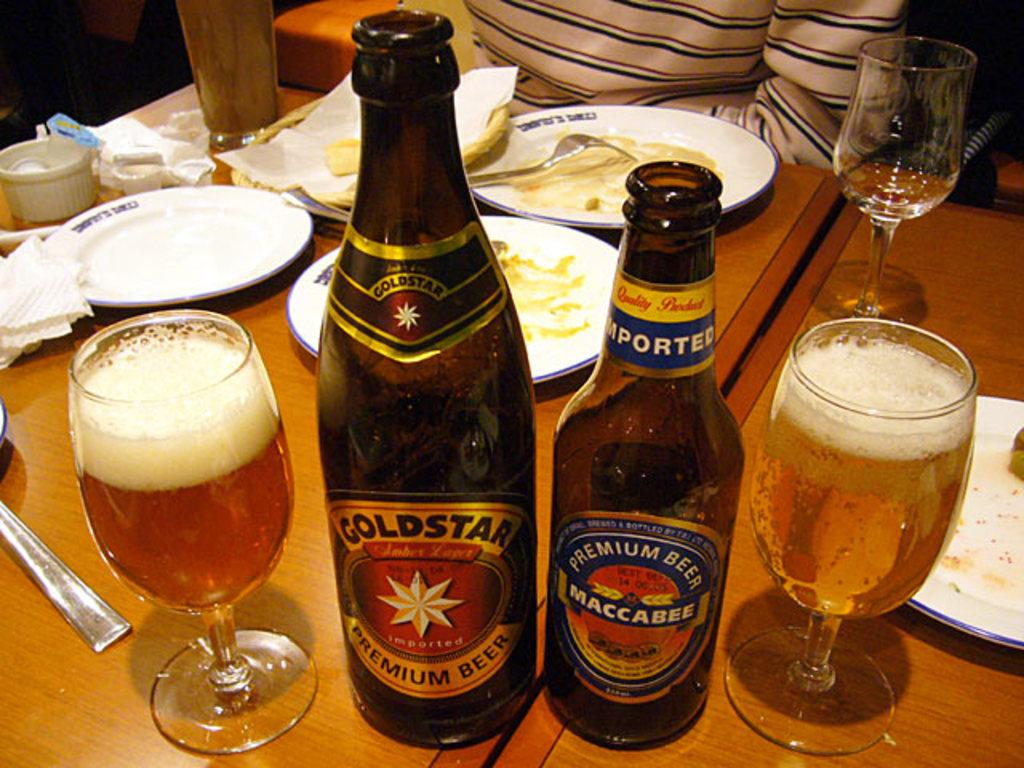What piece of furniture is present in the image? There is a table in the image. What items are placed on the table? There are plates, glasses, bottles, and dishes on the table. Is there any covering on the table? Yes, there is a cloth on the table. What is the acoustics like in the room where the table is located? The provided facts do not mention any information about the acoustics in the room, so it cannot be determined from the image. 